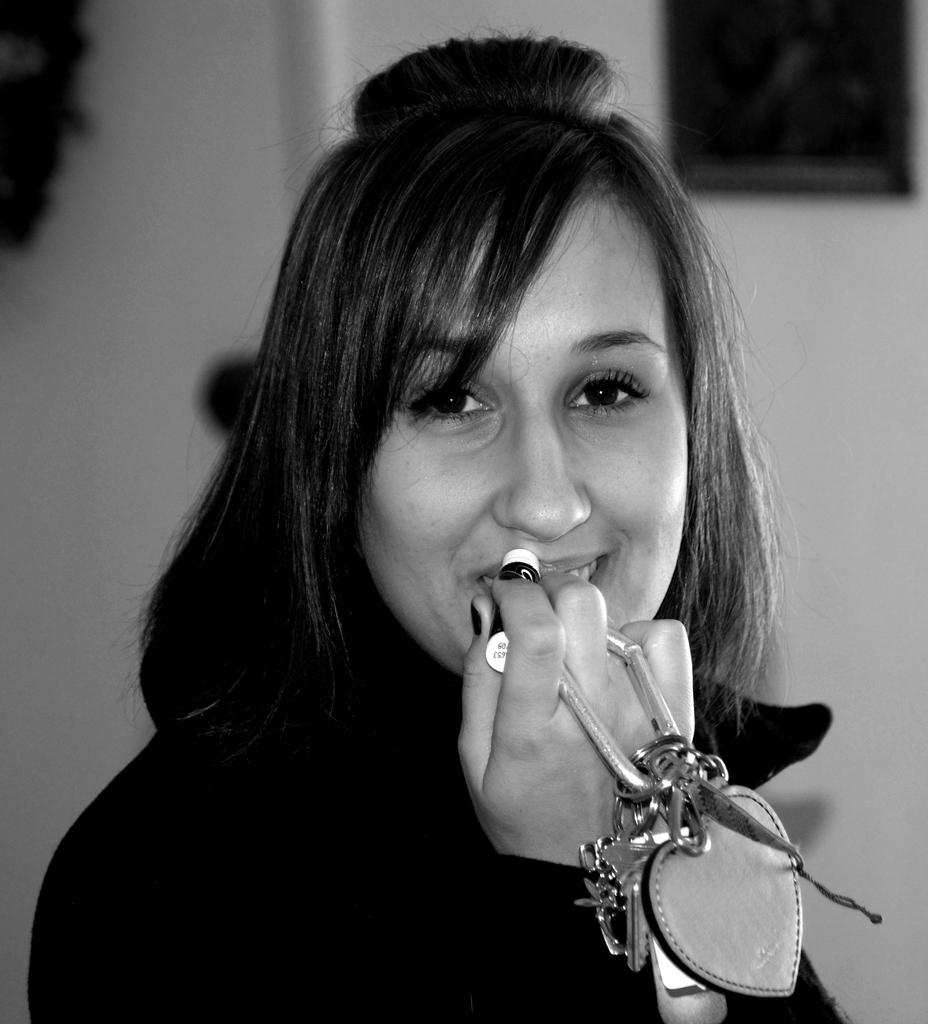What is the person in the image doing? The person is standing in the image and holding a key chain. What else is the person holding in the image? The person is holding an object, which is not specified in the facts. Can you describe the background of the image? The background of the image is blurred. What type of cast can be seen on the person's arm in the image? There is no cast visible on the person's arm in the image. Is the person in the image a woman? The gender of the person in the image is not specified in the facts. What amusement park can be seen in the background of the image? There is no amusement park or any indication of an amusement park in the background of the image. 